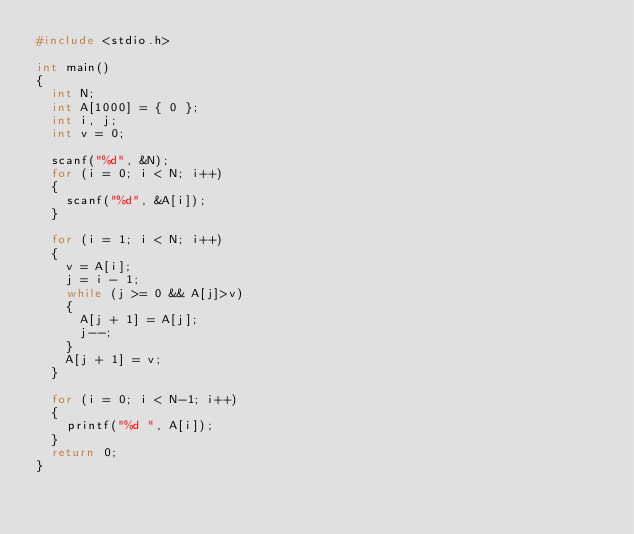Convert code to text. <code><loc_0><loc_0><loc_500><loc_500><_C_>#include <stdio.h>

int main()
{
	int N;
	int A[1000] = { 0 };
	int i, j;
	int v = 0;

	scanf("%d", &N);
	for (i = 0; i < N; i++)
	{
		scanf("%d", &A[i]);
	}

	for (i = 1; i < N; i++)
	{
		v = A[i];
		j = i - 1;
		while (j >= 0 && A[j]>v)
		{
			A[j + 1] = A[j];
			j--;
		}
		A[j + 1] = v;
	}

	for (i = 0; i < N-1; i++)
	{
		printf("%d ", A[i]);
	}
	return 0;
}</code> 